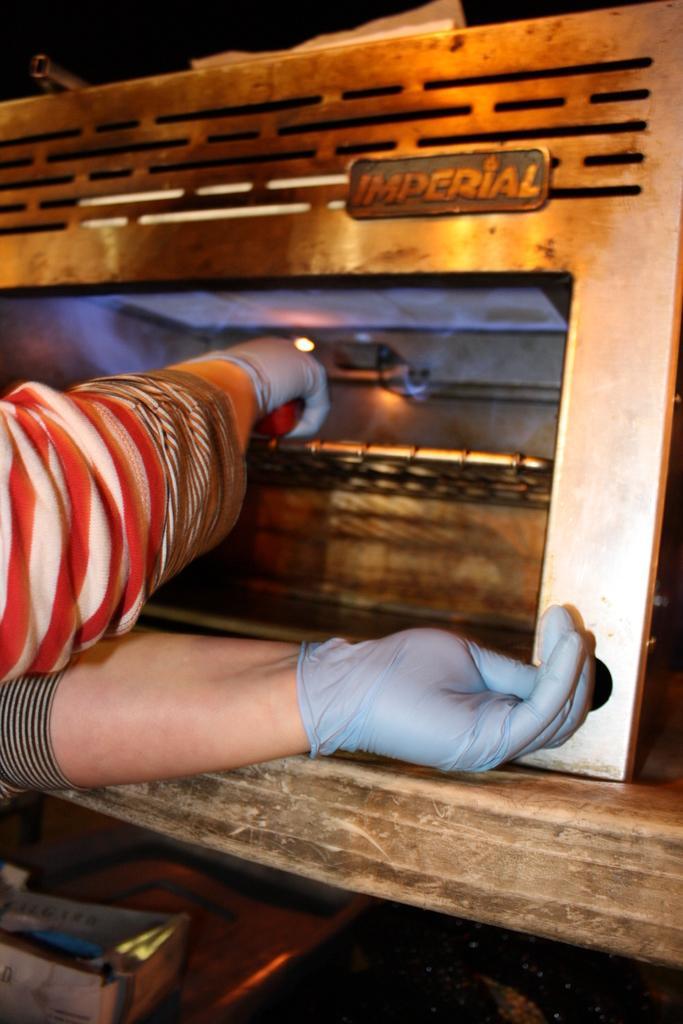Describe this image in one or two sentences. As we can see in the image there is a human hand and an oven. 